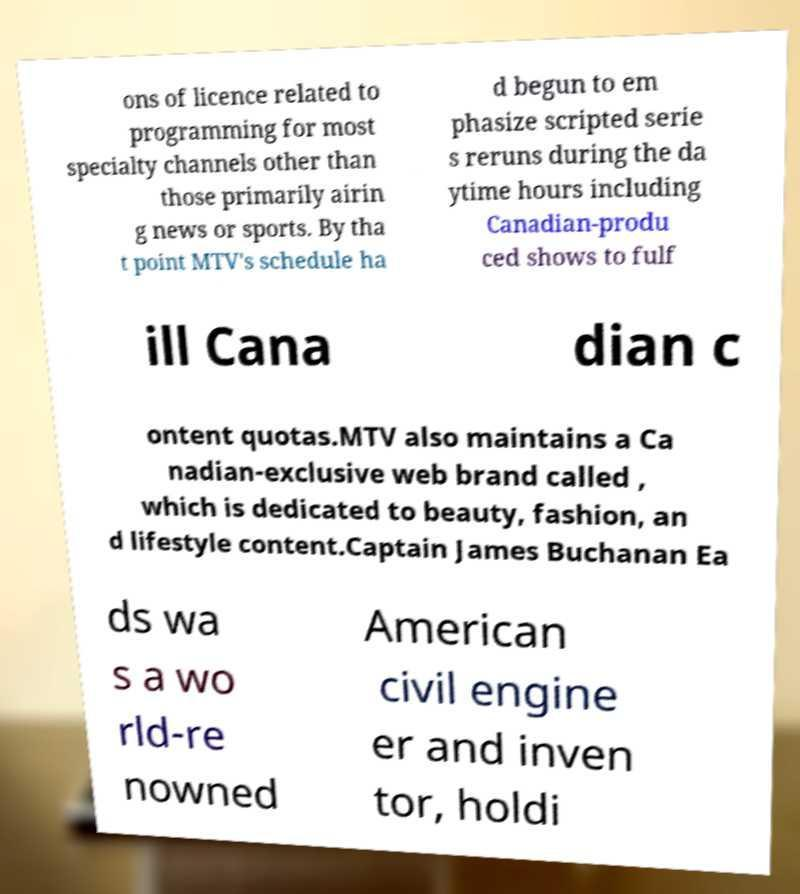Can you read and provide the text displayed in the image?This photo seems to have some interesting text. Can you extract and type it out for me? ons of licence related to programming for most specialty channels other than those primarily airin g news or sports. By tha t point MTV's schedule ha d begun to em phasize scripted serie s reruns during the da ytime hours including Canadian-produ ced shows to fulf ill Cana dian c ontent quotas.MTV also maintains a Ca nadian-exclusive web brand called , which is dedicated to beauty, fashion, an d lifestyle content.Captain James Buchanan Ea ds wa s a wo rld-re nowned American civil engine er and inven tor, holdi 